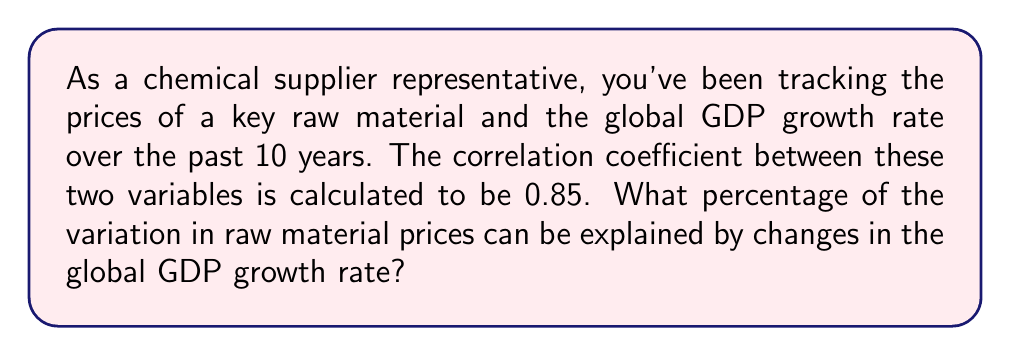Show me your answer to this math problem. To solve this problem, we need to understand the concept of the coefficient of determination, also known as R-squared.

1. The correlation coefficient (r) is given as 0.85.

2. The coefficient of determination (R-squared) is the square of the correlation coefficient:

   $$R^2 = r^2$$

3. Calculate R-squared:
   $$R^2 = (0.85)^2 = 0.7225$$

4. Convert to percentage:
   $$0.7225 \times 100\% = 72.25\%$$

5. Interpretation: 72.25% of the variation in raw material prices can be explained by changes in the global GDP growth rate.

This high percentage indicates a strong relationship between raw material prices and global economic indicators, which is valuable information for a chemical supplier representative in predicting price trends and developing cost-effective solutions for clients.
Answer: 72.25% 